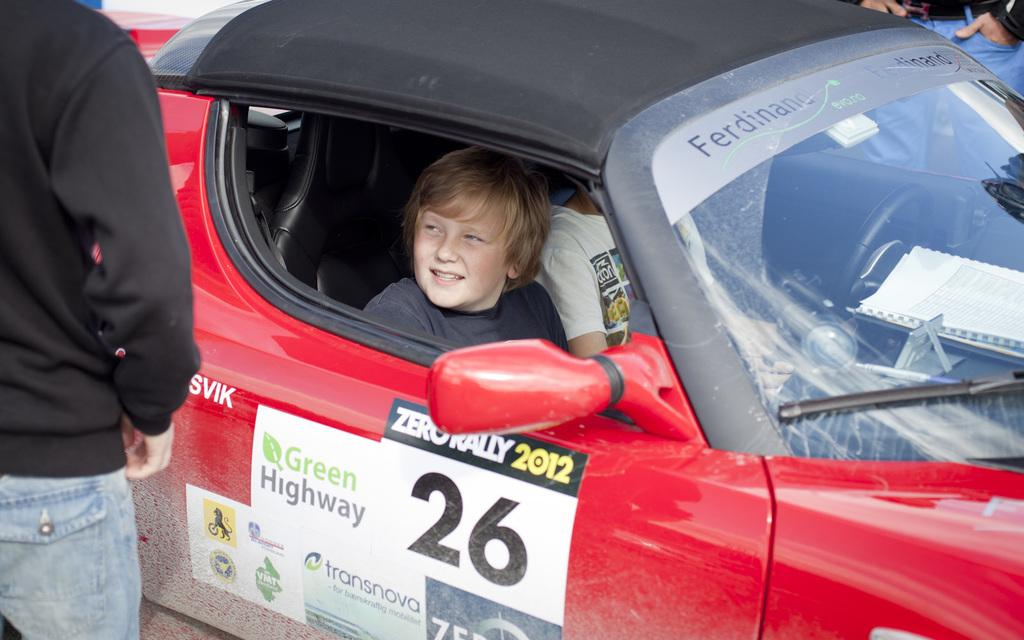What are the people in the image doing? The people in the image are sitting in a car. Can you describe the person near the car? There is a person standing near the car. What disease is the person standing near the car suffering from in the image? There is no information about any diseases in the image, and therefore it cannot be determined from the image. 